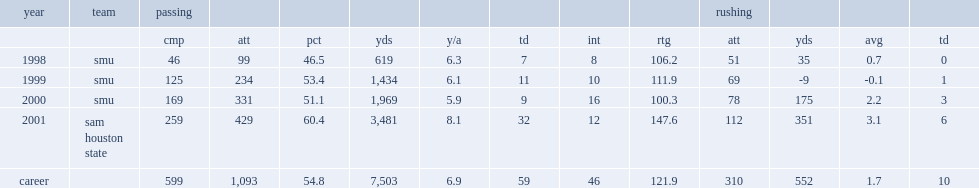How many interceptions did josh mccown get in 2001? 12.0. 